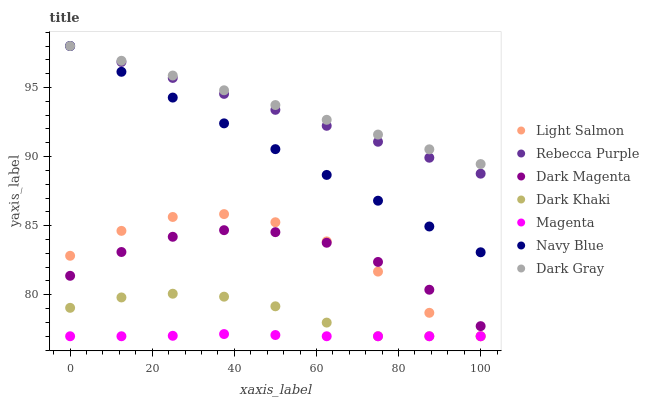Does Magenta have the minimum area under the curve?
Answer yes or no. Yes. Does Dark Gray have the maximum area under the curve?
Answer yes or no. Yes. Does Light Salmon have the minimum area under the curve?
Answer yes or no. No. Does Light Salmon have the maximum area under the curve?
Answer yes or no. No. Is Dark Gray the smoothest?
Answer yes or no. Yes. Is Light Salmon the roughest?
Answer yes or no. Yes. Is Dark Magenta the smoothest?
Answer yes or no. No. Is Dark Magenta the roughest?
Answer yes or no. No. Does Light Salmon have the lowest value?
Answer yes or no. Yes. Does Dark Magenta have the lowest value?
Answer yes or no. No. Does Rebecca Purple have the highest value?
Answer yes or no. Yes. Does Light Salmon have the highest value?
Answer yes or no. No. Is Light Salmon less than Dark Gray?
Answer yes or no. Yes. Is Navy Blue greater than Magenta?
Answer yes or no. Yes. Does Navy Blue intersect Dark Gray?
Answer yes or no. Yes. Is Navy Blue less than Dark Gray?
Answer yes or no. No. Is Navy Blue greater than Dark Gray?
Answer yes or no. No. Does Light Salmon intersect Dark Gray?
Answer yes or no. No. 